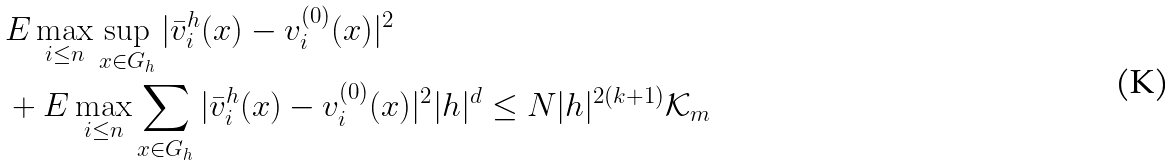<formula> <loc_0><loc_0><loc_500><loc_500>& E \max _ { i \leq n } \sup _ { x \in G _ { h } } | \bar { v } ^ { h } _ { i } ( x ) - v ^ { ( 0 ) } _ { i } ( x ) | ^ { 2 } \\ & + E \max _ { i \leq n } \sum _ { x \in G _ { h } } | \bar { v } ^ { h } _ { i } ( x ) - v ^ { ( 0 ) } _ { i } ( x ) | ^ { 2 } | h | ^ { d } \leq N | h | ^ { 2 ( k + 1 ) } \mathcal { K } _ { m }</formula> 